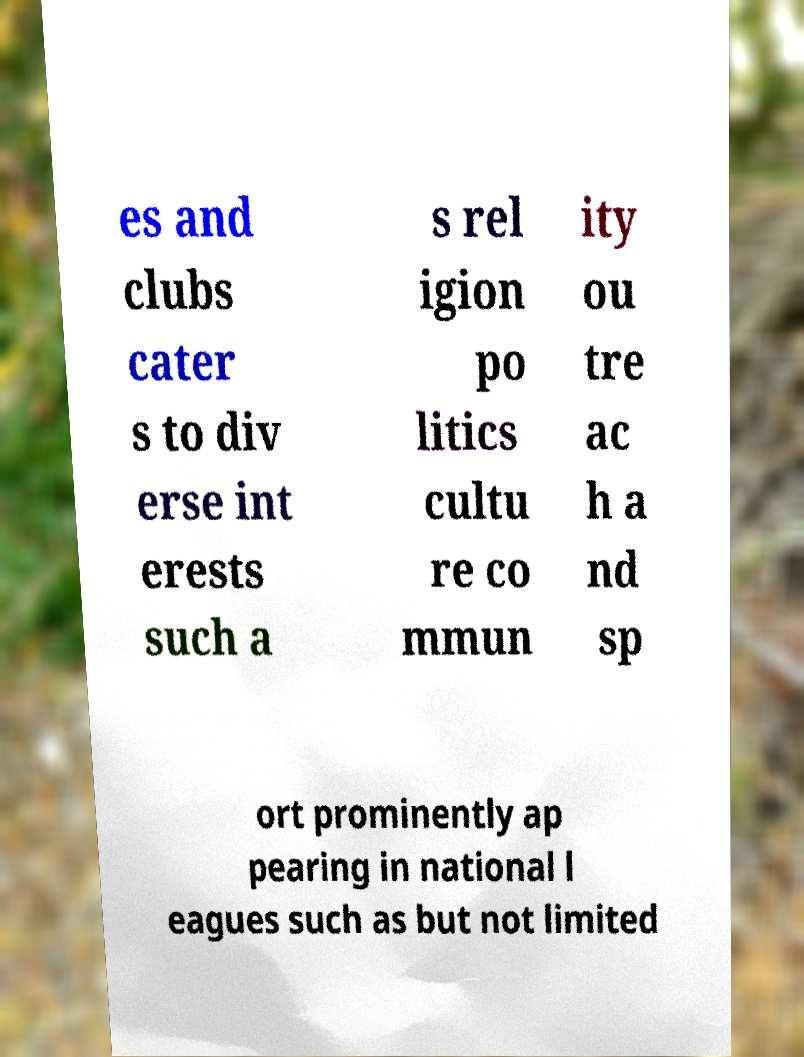Can you accurately transcribe the text from the provided image for me? es and clubs cater s to div erse int erests such a s rel igion po litics cultu re co mmun ity ou tre ac h a nd sp ort prominently ap pearing in national l eagues such as but not limited 